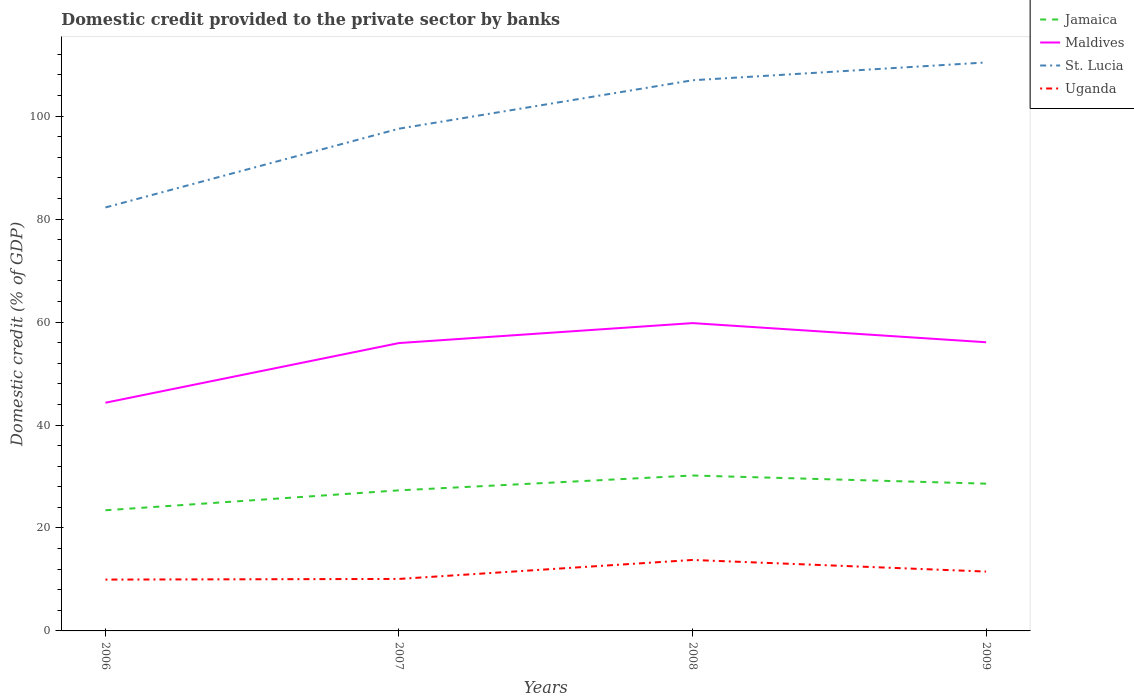How many different coloured lines are there?
Provide a short and direct response. 4. Does the line corresponding to Maldives intersect with the line corresponding to Uganda?
Make the answer very short. No. Is the number of lines equal to the number of legend labels?
Give a very brief answer. Yes. Across all years, what is the maximum domestic credit provided to the private sector by banks in Uganda?
Make the answer very short. 9.97. What is the total domestic credit provided to the private sector by banks in Uganda in the graph?
Your answer should be very brief. -3.82. What is the difference between the highest and the second highest domestic credit provided to the private sector by banks in St. Lucia?
Your response must be concise. 28.18. Is the domestic credit provided to the private sector by banks in Uganda strictly greater than the domestic credit provided to the private sector by banks in Jamaica over the years?
Keep it short and to the point. Yes. How many lines are there?
Your response must be concise. 4. Are the values on the major ticks of Y-axis written in scientific E-notation?
Keep it short and to the point. No. Does the graph contain any zero values?
Your answer should be compact. No. Does the graph contain grids?
Your response must be concise. No. How are the legend labels stacked?
Offer a terse response. Vertical. What is the title of the graph?
Your answer should be compact. Domestic credit provided to the private sector by banks. Does "Middle East & North Africa (developing only)" appear as one of the legend labels in the graph?
Your answer should be compact. No. What is the label or title of the X-axis?
Keep it short and to the point. Years. What is the label or title of the Y-axis?
Your response must be concise. Domestic credit (% of GDP). What is the Domestic credit (% of GDP) in Jamaica in 2006?
Your answer should be compact. 23.44. What is the Domestic credit (% of GDP) of Maldives in 2006?
Offer a very short reply. 44.33. What is the Domestic credit (% of GDP) in St. Lucia in 2006?
Ensure brevity in your answer.  82.26. What is the Domestic credit (% of GDP) in Uganda in 2006?
Your response must be concise. 9.97. What is the Domestic credit (% of GDP) of Jamaica in 2007?
Provide a short and direct response. 27.31. What is the Domestic credit (% of GDP) of Maldives in 2007?
Keep it short and to the point. 55.92. What is the Domestic credit (% of GDP) of St. Lucia in 2007?
Provide a succinct answer. 97.56. What is the Domestic credit (% of GDP) of Uganda in 2007?
Provide a succinct answer. 10.1. What is the Domestic credit (% of GDP) of Jamaica in 2008?
Offer a terse response. 30.19. What is the Domestic credit (% of GDP) in Maldives in 2008?
Make the answer very short. 59.8. What is the Domestic credit (% of GDP) in St. Lucia in 2008?
Give a very brief answer. 106.97. What is the Domestic credit (% of GDP) of Uganda in 2008?
Offer a terse response. 13.79. What is the Domestic credit (% of GDP) of Jamaica in 2009?
Provide a succinct answer. 28.61. What is the Domestic credit (% of GDP) of Maldives in 2009?
Offer a terse response. 56.07. What is the Domestic credit (% of GDP) of St. Lucia in 2009?
Your response must be concise. 110.43. What is the Domestic credit (% of GDP) in Uganda in 2009?
Your answer should be very brief. 11.53. Across all years, what is the maximum Domestic credit (% of GDP) in Jamaica?
Keep it short and to the point. 30.19. Across all years, what is the maximum Domestic credit (% of GDP) in Maldives?
Make the answer very short. 59.8. Across all years, what is the maximum Domestic credit (% of GDP) in St. Lucia?
Keep it short and to the point. 110.43. Across all years, what is the maximum Domestic credit (% of GDP) of Uganda?
Provide a succinct answer. 13.79. Across all years, what is the minimum Domestic credit (% of GDP) in Jamaica?
Your answer should be very brief. 23.44. Across all years, what is the minimum Domestic credit (% of GDP) in Maldives?
Give a very brief answer. 44.33. Across all years, what is the minimum Domestic credit (% of GDP) of St. Lucia?
Give a very brief answer. 82.26. Across all years, what is the minimum Domestic credit (% of GDP) of Uganda?
Your response must be concise. 9.97. What is the total Domestic credit (% of GDP) of Jamaica in the graph?
Offer a terse response. 109.54. What is the total Domestic credit (% of GDP) of Maldives in the graph?
Offer a terse response. 216.11. What is the total Domestic credit (% of GDP) in St. Lucia in the graph?
Keep it short and to the point. 397.22. What is the total Domestic credit (% of GDP) of Uganda in the graph?
Provide a succinct answer. 45.38. What is the difference between the Domestic credit (% of GDP) of Jamaica in 2006 and that in 2007?
Provide a succinct answer. -3.87. What is the difference between the Domestic credit (% of GDP) in Maldives in 2006 and that in 2007?
Ensure brevity in your answer.  -11.59. What is the difference between the Domestic credit (% of GDP) of St. Lucia in 2006 and that in 2007?
Offer a terse response. -15.31. What is the difference between the Domestic credit (% of GDP) in Uganda in 2006 and that in 2007?
Provide a succinct answer. -0.13. What is the difference between the Domestic credit (% of GDP) in Jamaica in 2006 and that in 2008?
Provide a short and direct response. -6.75. What is the difference between the Domestic credit (% of GDP) of Maldives in 2006 and that in 2008?
Make the answer very short. -15.47. What is the difference between the Domestic credit (% of GDP) in St. Lucia in 2006 and that in 2008?
Your response must be concise. -24.71. What is the difference between the Domestic credit (% of GDP) of Uganda in 2006 and that in 2008?
Your answer should be compact. -3.82. What is the difference between the Domestic credit (% of GDP) in Jamaica in 2006 and that in 2009?
Provide a short and direct response. -5.17. What is the difference between the Domestic credit (% of GDP) in Maldives in 2006 and that in 2009?
Offer a terse response. -11.75. What is the difference between the Domestic credit (% of GDP) of St. Lucia in 2006 and that in 2009?
Provide a succinct answer. -28.18. What is the difference between the Domestic credit (% of GDP) of Uganda in 2006 and that in 2009?
Ensure brevity in your answer.  -1.56. What is the difference between the Domestic credit (% of GDP) in Jamaica in 2007 and that in 2008?
Your answer should be compact. -2.88. What is the difference between the Domestic credit (% of GDP) of Maldives in 2007 and that in 2008?
Offer a terse response. -3.88. What is the difference between the Domestic credit (% of GDP) in St. Lucia in 2007 and that in 2008?
Your answer should be compact. -9.41. What is the difference between the Domestic credit (% of GDP) in Uganda in 2007 and that in 2008?
Ensure brevity in your answer.  -3.69. What is the difference between the Domestic credit (% of GDP) of Jamaica in 2007 and that in 2009?
Offer a very short reply. -1.3. What is the difference between the Domestic credit (% of GDP) of Maldives in 2007 and that in 2009?
Offer a very short reply. -0.16. What is the difference between the Domestic credit (% of GDP) in St. Lucia in 2007 and that in 2009?
Ensure brevity in your answer.  -12.87. What is the difference between the Domestic credit (% of GDP) of Uganda in 2007 and that in 2009?
Your response must be concise. -1.43. What is the difference between the Domestic credit (% of GDP) in Jamaica in 2008 and that in 2009?
Make the answer very short. 1.58. What is the difference between the Domestic credit (% of GDP) in Maldives in 2008 and that in 2009?
Provide a short and direct response. 3.72. What is the difference between the Domestic credit (% of GDP) of St. Lucia in 2008 and that in 2009?
Provide a short and direct response. -3.46. What is the difference between the Domestic credit (% of GDP) in Uganda in 2008 and that in 2009?
Offer a very short reply. 2.26. What is the difference between the Domestic credit (% of GDP) in Jamaica in 2006 and the Domestic credit (% of GDP) in Maldives in 2007?
Offer a terse response. -32.48. What is the difference between the Domestic credit (% of GDP) in Jamaica in 2006 and the Domestic credit (% of GDP) in St. Lucia in 2007?
Make the answer very short. -74.12. What is the difference between the Domestic credit (% of GDP) in Jamaica in 2006 and the Domestic credit (% of GDP) in Uganda in 2007?
Keep it short and to the point. 13.34. What is the difference between the Domestic credit (% of GDP) in Maldives in 2006 and the Domestic credit (% of GDP) in St. Lucia in 2007?
Your answer should be very brief. -53.24. What is the difference between the Domestic credit (% of GDP) in Maldives in 2006 and the Domestic credit (% of GDP) in Uganda in 2007?
Ensure brevity in your answer.  34.23. What is the difference between the Domestic credit (% of GDP) in St. Lucia in 2006 and the Domestic credit (% of GDP) in Uganda in 2007?
Your answer should be very brief. 72.16. What is the difference between the Domestic credit (% of GDP) in Jamaica in 2006 and the Domestic credit (% of GDP) in Maldives in 2008?
Provide a succinct answer. -36.36. What is the difference between the Domestic credit (% of GDP) in Jamaica in 2006 and the Domestic credit (% of GDP) in St. Lucia in 2008?
Make the answer very short. -83.53. What is the difference between the Domestic credit (% of GDP) of Jamaica in 2006 and the Domestic credit (% of GDP) of Uganda in 2008?
Your response must be concise. 9.65. What is the difference between the Domestic credit (% of GDP) of Maldives in 2006 and the Domestic credit (% of GDP) of St. Lucia in 2008?
Your response must be concise. -62.64. What is the difference between the Domestic credit (% of GDP) in Maldives in 2006 and the Domestic credit (% of GDP) in Uganda in 2008?
Offer a terse response. 30.54. What is the difference between the Domestic credit (% of GDP) of St. Lucia in 2006 and the Domestic credit (% of GDP) of Uganda in 2008?
Your response must be concise. 68.47. What is the difference between the Domestic credit (% of GDP) in Jamaica in 2006 and the Domestic credit (% of GDP) in Maldives in 2009?
Offer a very short reply. -32.64. What is the difference between the Domestic credit (% of GDP) of Jamaica in 2006 and the Domestic credit (% of GDP) of St. Lucia in 2009?
Give a very brief answer. -86.99. What is the difference between the Domestic credit (% of GDP) of Jamaica in 2006 and the Domestic credit (% of GDP) of Uganda in 2009?
Your response must be concise. 11.91. What is the difference between the Domestic credit (% of GDP) in Maldives in 2006 and the Domestic credit (% of GDP) in St. Lucia in 2009?
Offer a very short reply. -66.1. What is the difference between the Domestic credit (% of GDP) in Maldives in 2006 and the Domestic credit (% of GDP) in Uganda in 2009?
Provide a succinct answer. 32.8. What is the difference between the Domestic credit (% of GDP) in St. Lucia in 2006 and the Domestic credit (% of GDP) in Uganda in 2009?
Your answer should be compact. 70.73. What is the difference between the Domestic credit (% of GDP) in Jamaica in 2007 and the Domestic credit (% of GDP) in Maldives in 2008?
Provide a short and direct response. -32.49. What is the difference between the Domestic credit (% of GDP) of Jamaica in 2007 and the Domestic credit (% of GDP) of St. Lucia in 2008?
Offer a very short reply. -79.66. What is the difference between the Domestic credit (% of GDP) in Jamaica in 2007 and the Domestic credit (% of GDP) in Uganda in 2008?
Offer a very short reply. 13.52. What is the difference between the Domestic credit (% of GDP) of Maldives in 2007 and the Domestic credit (% of GDP) of St. Lucia in 2008?
Offer a very short reply. -51.05. What is the difference between the Domestic credit (% of GDP) in Maldives in 2007 and the Domestic credit (% of GDP) in Uganda in 2008?
Provide a short and direct response. 42.13. What is the difference between the Domestic credit (% of GDP) of St. Lucia in 2007 and the Domestic credit (% of GDP) of Uganda in 2008?
Keep it short and to the point. 83.78. What is the difference between the Domestic credit (% of GDP) of Jamaica in 2007 and the Domestic credit (% of GDP) of Maldives in 2009?
Offer a terse response. -28.77. What is the difference between the Domestic credit (% of GDP) in Jamaica in 2007 and the Domestic credit (% of GDP) in St. Lucia in 2009?
Offer a terse response. -83.12. What is the difference between the Domestic credit (% of GDP) of Jamaica in 2007 and the Domestic credit (% of GDP) of Uganda in 2009?
Make the answer very short. 15.78. What is the difference between the Domestic credit (% of GDP) of Maldives in 2007 and the Domestic credit (% of GDP) of St. Lucia in 2009?
Ensure brevity in your answer.  -54.51. What is the difference between the Domestic credit (% of GDP) in Maldives in 2007 and the Domestic credit (% of GDP) in Uganda in 2009?
Ensure brevity in your answer.  44.39. What is the difference between the Domestic credit (% of GDP) in St. Lucia in 2007 and the Domestic credit (% of GDP) in Uganda in 2009?
Your answer should be very brief. 86.03. What is the difference between the Domestic credit (% of GDP) in Jamaica in 2008 and the Domestic credit (% of GDP) in Maldives in 2009?
Keep it short and to the point. -25.88. What is the difference between the Domestic credit (% of GDP) of Jamaica in 2008 and the Domestic credit (% of GDP) of St. Lucia in 2009?
Keep it short and to the point. -80.24. What is the difference between the Domestic credit (% of GDP) of Jamaica in 2008 and the Domestic credit (% of GDP) of Uganda in 2009?
Make the answer very short. 18.66. What is the difference between the Domestic credit (% of GDP) of Maldives in 2008 and the Domestic credit (% of GDP) of St. Lucia in 2009?
Offer a very short reply. -50.64. What is the difference between the Domestic credit (% of GDP) of Maldives in 2008 and the Domestic credit (% of GDP) of Uganda in 2009?
Give a very brief answer. 48.27. What is the difference between the Domestic credit (% of GDP) in St. Lucia in 2008 and the Domestic credit (% of GDP) in Uganda in 2009?
Your answer should be very brief. 95.44. What is the average Domestic credit (% of GDP) in Jamaica per year?
Offer a terse response. 27.39. What is the average Domestic credit (% of GDP) in Maldives per year?
Your answer should be compact. 54.03. What is the average Domestic credit (% of GDP) of St. Lucia per year?
Your response must be concise. 99.3. What is the average Domestic credit (% of GDP) of Uganda per year?
Your answer should be very brief. 11.35. In the year 2006, what is the difference between the Domestic credit (% of GDP) of Jamaica and Domestic credit (% of GDP) of Maldives?
Your answer should be compact. -20.89. In the year 2006, what is the difference between the Domestic credit (% of GDP) in Jamaica and Domestic credit (% of GDP) in St. Lucia?
Ensure brevity in your answer.  -58.82. In the year 2006, what is the difference between the Domestic credit (% of GDP) of Jamaica and Domestic credit (% of GDP) of Uganda?
Give a very brief answer. 13.47. In the year 2006, what is the difference between the Domestic credit (% of GDP) of Maldives and Domestic credit (% of GDP) of St. Lucia?
Make the answer very short. -37.93. In the year 2006, what is the difference between the Domestic credit (% of GDP) in Maldives and Domestic credit (% of GDP) in Uganda?
Your answer should be very brief. 34.36. In the year 2006, what is the difference between the Domestic credit (% of GDP) of St. Lucia and Domestic credit (% of GDP) of Uganda?
Give a very brief answer. 72.29. In the year 2007, what is the difference between the Domestic credit (% of GDP) in Jamaica and Domestic credit (% of GDP) in Maldives?
Keep it short and to the point. -28.61. In the year 2007, what is the difference between the Domestic credit (% of GDP) in Jamaica and Domestic credit (% of GDP) in St. Lucia?
Your answer should be compact. -70.26. In the year 2007, what is the difference between the Domestic credit (% of GDP) in Jamaica and Domestic credit (% of GDP) in Uganda?
Provide a succinct answer. 17.21. In the year 2007, what is the difference between the Domestic credit (% of GDP) of Maldives and Domestic credit (% of GDP) of St. Lucia?
Offer a very short reply. -41.65. In the year 2007, what is the difference between the Domestic credit (% of GDP) in Maldives and Domestic credit (% of GDP) in Uganda?
Your response must be concise. 45.82. In the year 2007, what is the difference between the Domestic credit (% of GDP) of St. Lucia and Domestic credit (% of GDP) of Uganda?
Provide a short and direct response. 87.46. In the year 2008, what is the difference between the Domestic credit (% of GDP) in Jamaica and Domestic credit (% of GDP) in Maldives?
Offer a terse response. -29.6. In the year 2008, what is the difference between the Domestic credit (% of GDP) in Jamaica and Domestic credit (% of GDP) in St. Lucia?
Keep it short and to the point. -76.78. In the year 2008, what is the difference between the Domestic credit (% of GDP) in Jamaica and Domestic credit (% of GDP) in Uganda?
Make the answer very short. 16.41. In the year 2008, what is the difference between the Domestic credit (% of GDP) in Maldives and Domestic credit (% of GDP) in St. Lucia?
Your answer should be compact. -47.17. In the year 2008, what is the difference between the Domestic credit (% of GDP) of Maldives and Domestic credit (% of GDP) of Uganda?
Give a very brief answer. 46.01. In the year 2008, what is the difference between the Domestic credit (% of GDP) of St. Lucia and Domestic credit (% of GDP) of Uganda?
Give a very brief answer. 93.18. In the year 2009, what is the difference between the Domestic credit (% of GDP) in Jamaica and Domestic credit (% of GDP) in Maldives?
Keep it short and to the point. -27.47. In the year 2009, what is the difference between the Domestic credit (% of GDP) in Jamaica and Domestic credit (% of GDP) in St. Lucia?
Provide a succinct answer. -81.82. In the year 2009, what is the difference between the Domestic credit (% of GDP) of Jamaica and Domestic credit (% of GDP) of Uganda?
Give a very brief answer. 17.08. In the year 2009, what is the difference between the Domestic credit (% of GDP) of Maldives and Domestic credit (% of GDP) of St. Lucia?
Make the answer very short. -54.36. In the year 2009, what is the difference between the Domestic credit (% of GDP) in Maldives and Domestic credit (% of GDP) in Uganda?
Keep it short and to the point. 44.55. In the year 2009, what is the difference between the Domestic credit (% of GDP) in St. Lucia and Domestic credit (% of GDP) in Uganda?
Ensure brevity in your answer.  98.9. What is the ratio of the Domestic credit (% of GDP) in Jamaica in 2006 to that in 2007?
Your answer should be very brief. 0.86. What is the ratio of the Domestic credit (% of GDP) in Maldives in 2006 to that in 2007?
Provide a succinct answer. 0.79. What is the ratio of the Domestic credit (% of GDP) in St. Lucia in 2006 to that in 2007?
Your response must be concise. 0.84. What is the ratio of the Domestic credit (% of GDP) in Uganda in 2006 to that in 2007?
Your answer should be compact. 0.99. What is the ratio of the Domestic credit (% of GDP) of Jamaica in 2006 to that in 2008?
Your answer should be compact. 0.78. What is the ratio of the Domestic credit (% of GDP) of Maldives in 2006 to that in 2008?
Provide a short and direct response. 0.74. What is the ratio of the Domestic credit (% of GDP) in St. Lucia in 2006 to that in 2008?
Give a very brief answer. 0.77. What is the ratio of the Domestic credit (% of GDP) of Uganda in 2006 to that in 2008?
Provide a succinct answer. 0.72. What is the ratio of the Domestic credit (% of GDP) in Jamaica in 2006 to that in 2009?
Ensure brevity in your answer.  0.82. What is the ratio of the Domestic credit (% of GDP) in Maldives in 2006 to that in 2009?
Your answer should be compact. 0.79. What is the ratio of the Domestic credit (% of GDP) in St. Lucia in 2006 to that in 2009?
Your answer should be compact. 0.74. What is the ratio of the Domestic credit (% of GDP) in Uganda in 2006 to that in 2009?
Make the answer very short. 0.86. What is the ratio of the Domestic credit (% of GDP) in Jamaica in 2007 to that in 2008?
Provide a succinct answer. 0.9. What is the ratio of the Domestic credit (% of GDP) in Maldives in 2007 to that in 2008?
Your answer should be compact. 0.94. What is the ratio of the Domestic credit (% of GDP) in St. Lucia in 2007 to that in 2008?
Offer a very short reply. 0.91. What is the ratio of the Domestic credit (% of GDP) of Uganda in 2007 to that in 2008?
Offer a terse response. 0.73. What is the ratio of the Domestic credit (% of GDP) in Jamaica in 2007 to that in 2009?
Offer a terse response. 0.95. What is the ratio of the Domestic credit (% of GDP) in St. Lucia in 2007 to that in 2009?
Your answer should be very brief. 0.88. What is the ratio of the Domestic credit (% of GDP) in Uganda in 2007 to that in 2009?
Your answer should be compact. 0.88. What is the ratio of the Domestic credit (% of GDP) of Jamaica in 2008 to that in 2009?
Give a very brief answer. 1.06. What is the ratio of the Domestic credit (% of GDP) of Maldives in 2008 to that in 2009?
Give a very brief answer. 1.07. What is the ratio of the Domestic credit (% of GDP) in St. Lucia in 2008 to that in 2009?
Your response must be concise. 0.97. What is the ratio of the Domestic credit (% of GDP) in Uganda in 2008 to that in 2009?
Ensure brevity in your answer.  1.2. What is the difference between the highest and the second highest Domestic credit (% of GDP) of Jamaica?
Provide a succinct answer. 1.58. What is the difference between the highest and the second highest Domestic credit (% of GDP) of Maldives?
Offer a very short reply. 3.72. What is the difference between the highest and the second highest Domestic credit (% of GDP) of St. Lucia?
Ensure brevity in your answer.  3.46. What is the difference between the highest and the second highest Domestic credit (% of GDP) in Uganda?
Your answer should be very brief. 2.26. What is the difference between the highest and the lowest Domestic credit (% of GDP) of Jamaica?
Provide a short and direct response. 6.75. What is the difference between the highest and the lowest Domestic credit (% of GDP) of Maldives?
Give a very brief answer. 15.47. What is the difference between the highest and the lowest Domestic credit (% of GDP) in St. Lucia?
Your answer should be very brief. 28.18. What is the difference between the highest and the lowest Domestic credit (% of GDP) in Uganda?
Your response must be concise. 3.82. 